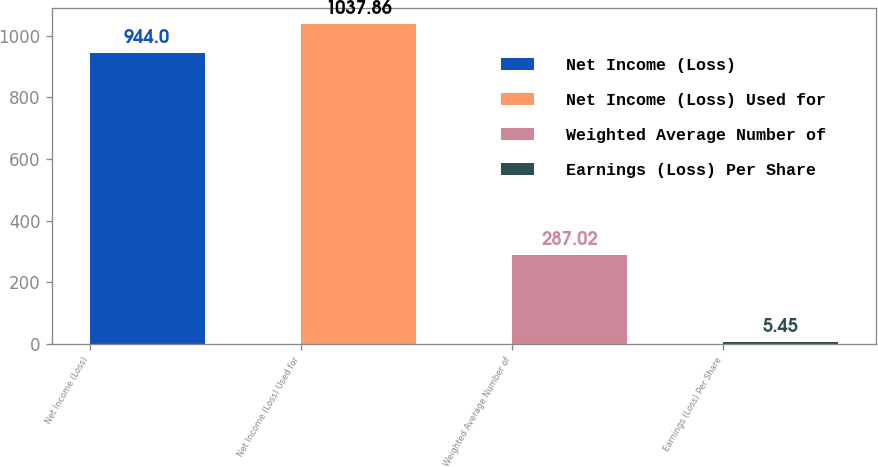<chart> <loc_0><loc_0><loc_500><loc_500><bar_chart><fcel>Net Income (Loss)<fcel>Net Income (Loss) Used for<fcel>Weighted Average Number of<fcel>Earnings (Loss) Per Share<nl><fcel>944<fcel>1037.86<fcel>287.02<fcel>5.45<nl></chart> 